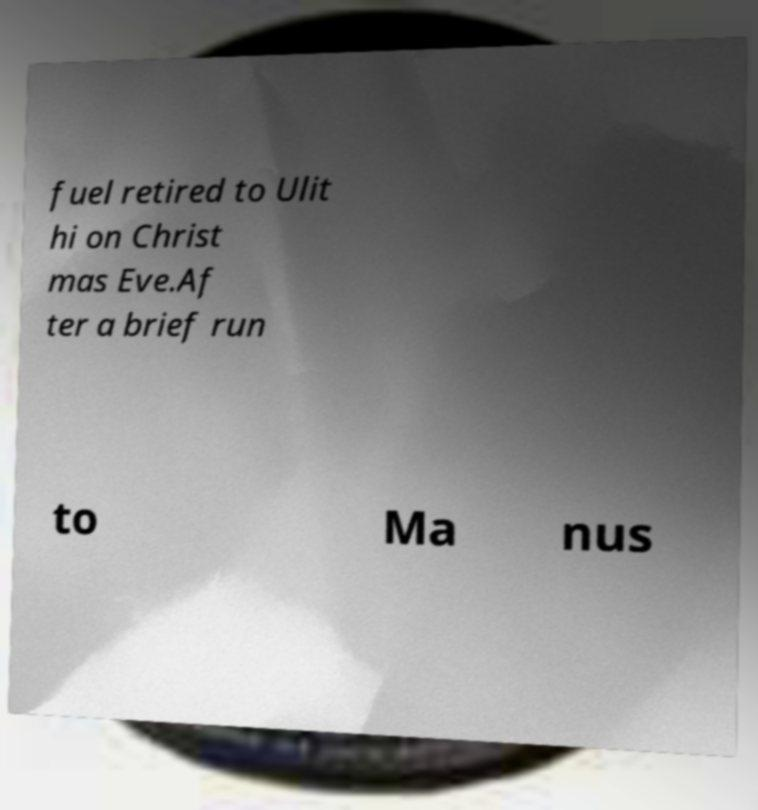Please read and relay the text visible in this image. What does it say? fuel retired to Ulit hi on Christ mas Eve.Af ter a brief run to Ma nus 